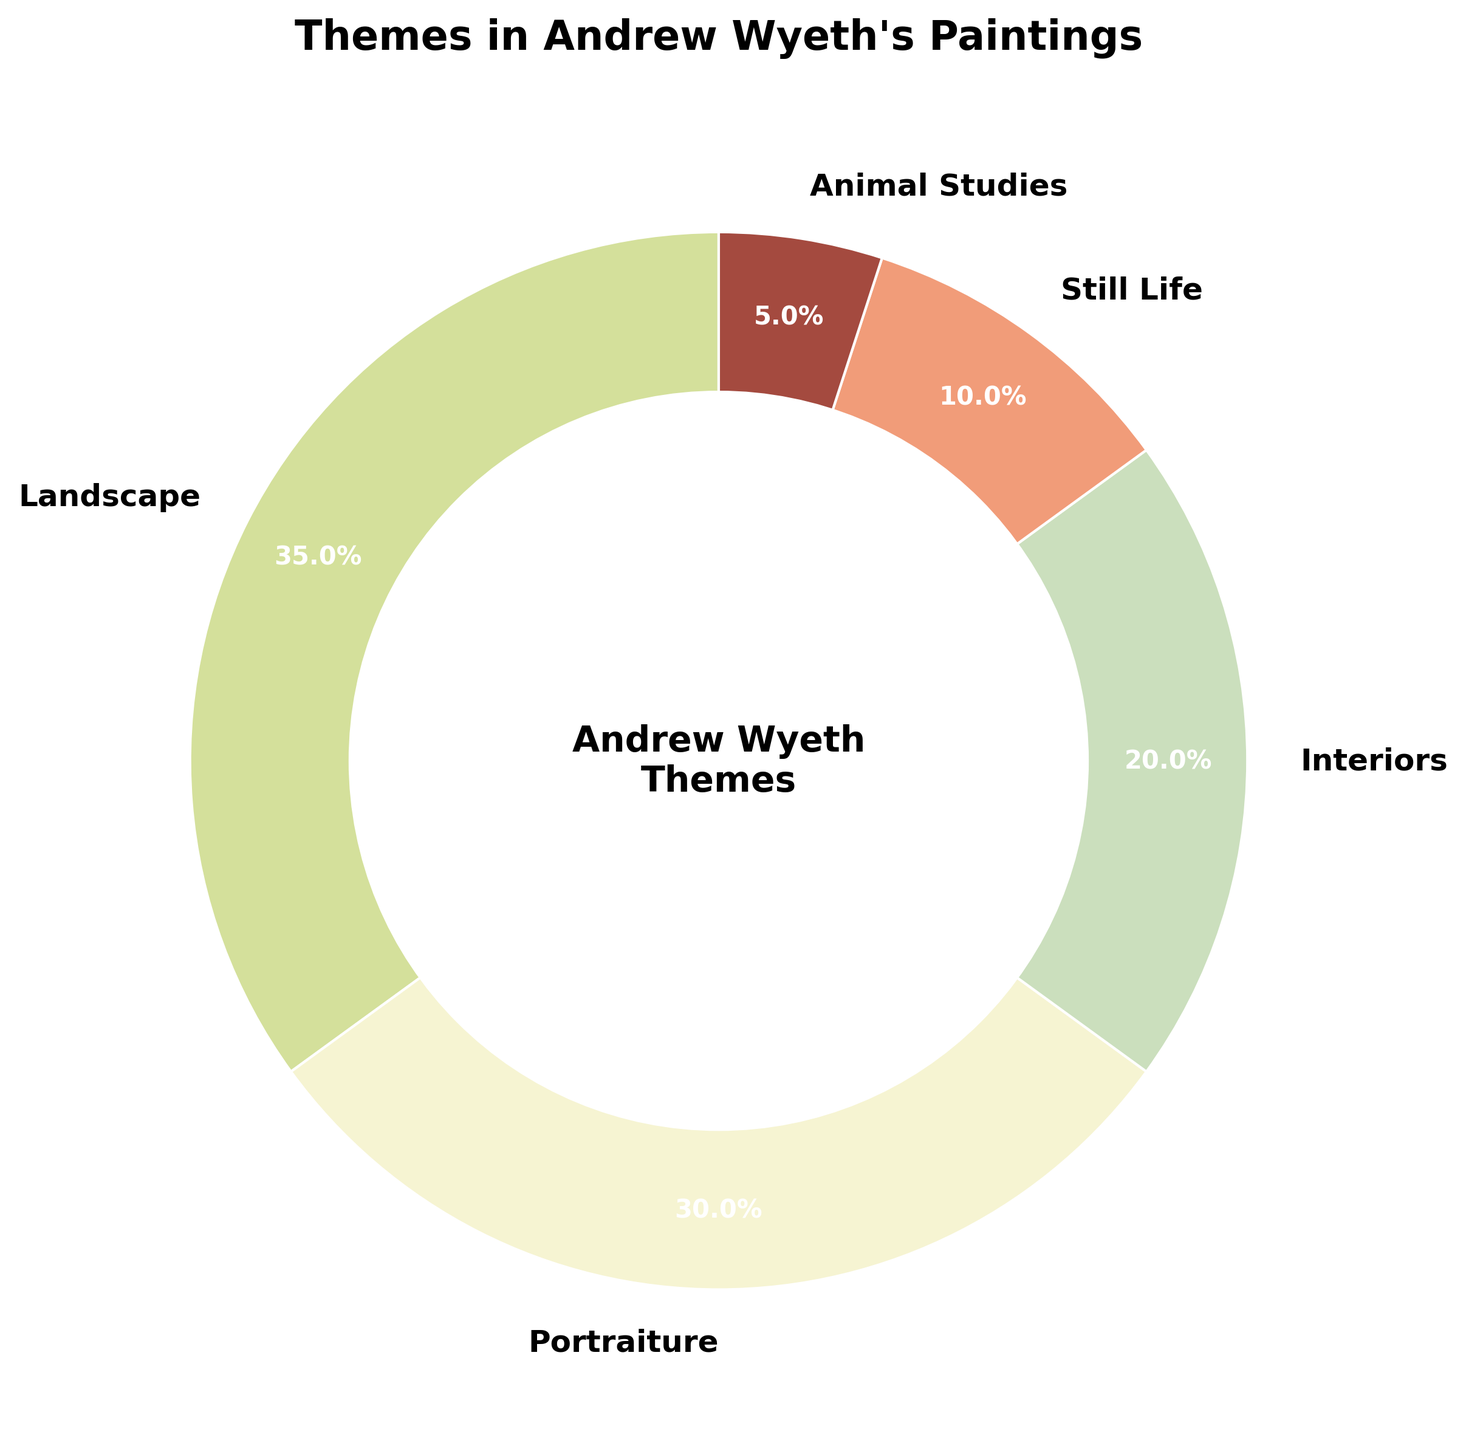what percentage of Andrew Wyeth's paintings include portraits? To find the percentage of portraiture-themed paintings, refer to the segment labeled "Portraiture" on the pie chart. The label indicates that portraits constitute 30% of Andrew Wyeth's works.
Answer: 30% how does the percentage of interior-themed paintings compare to still life-themed paintings? Compare the percentages of "Interiors" and "Still Life" segments in the pie chart. Interiors are 20% while Still Life is 10%, so interiors occupy a larger percentage.
Answer: Interiors are 10% more than Still Life what percentage of Wyeth's paintings feature landscapes or animal studies combined? Sum the percentages of "Landscape" and "Animal Studies" segments from the pie chart. Landscape is 35% and Animal Studies is 5%, so total is 35% + 5% = 40%.
Answer: 40% which theme occupies the largest percentage in Wyeth's paintings? Look at the segments in the pie chart to identify the theme with the highest percentage. The "Landscape" segment is the largest, indicating it occupies 35% of the paintings.
Answer: Landscape what is the difference in percentage between portraiture and still life themes? Subtract the percentage of the still life theme from the portraiture theme. Portraiture is 30%, and still life is 10%, so the difference is 30% - 10% = 20%.
Answer: 20% if you combine interior and portraiture themes, what percentage of Wyeth's paintings do they represent? Add the percentage values of "Interiors" and "Portraiture" segments. Interiors are 20% and Portraiture is 30%, so total is 20% + 30% = 50%.
Answer: 50% what color represents the "Landscape" theme in the pie chart? Identify the color corresponding to the "Landscape" label in the pie chart. The "Landscape" segment is colored in a shade of green.
Answer: Green 